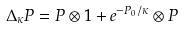Convert formula to latex. <formula><loc_0><loc_0><loc_500><loc_500>\Delta _ { \kappa } { P } = { P } \otimes 1 + e ^ { - P _ { 0 } / \kappa } \otimes { P }</formula> 